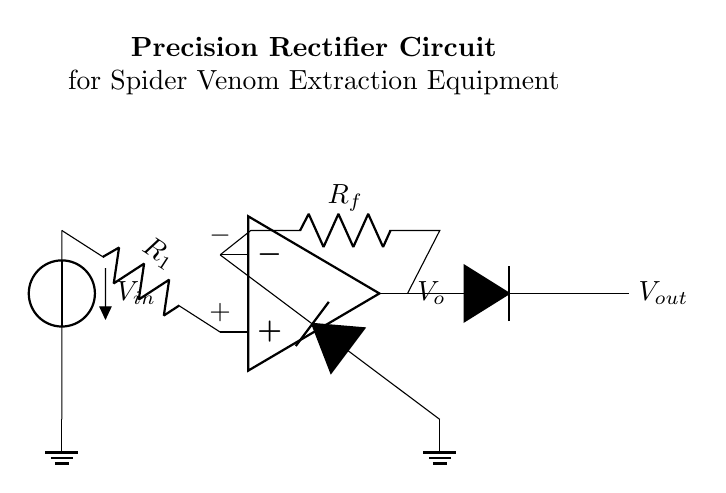What is the type of this circuit? This circuit is known as a precision rectifier, which is a specific type of rectifier designed to provide accurate output voltage levels, especially for small input signals.
Answer: precision rectifier What components are used in this circuit? The primary components in this circuit are an operational amplifier, resistors, and diodes, which are all connected to form the rectifier.
Answer: operational amplifier, resistors, diodes What is the function of the operational amplifier? The operational amplifier amplifies the input voltage, enabling the precision rectifier to work effectively by ensuring low output impedance and high input impedance, crucial for accurate measurements.
Answer: amplifies voltage What is the role of the feedback resistor? The feedback resistor connects the output of the operational amplifier back to its inverting input, creating a closed-loop which stabilizes the circuit and controls the gain of the amplifier.
Answer: stabilizes the circuit What happens to the output voltage when the input voltage is negative? When the input voltage is negative, the precision rectifier allows the output voltage to be zero, effectively blocking any negative voltage from appearing at the output, which is important for measuring absolute values.
Answer: output voltage is zero How does the precision rectifier improve measurement accuracy? The precision rectifier eliminates the voltage drop across traditional rectifier diodes, allowing for accurate measurement of small signals without losing fidelity due to diode forward voltage drop, resulting in better extraction of spider venom measurements.
Answer: eliminates diode voltage drop 